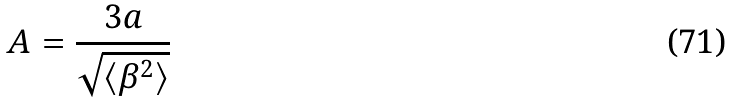Convert formula to latex. <formula><loc_0><loc_0><loc_500><loc_500>A = \frac { 3 a } { \sqrt { \langle \beta ^ { 2 } \rangle } } \,</formula> 